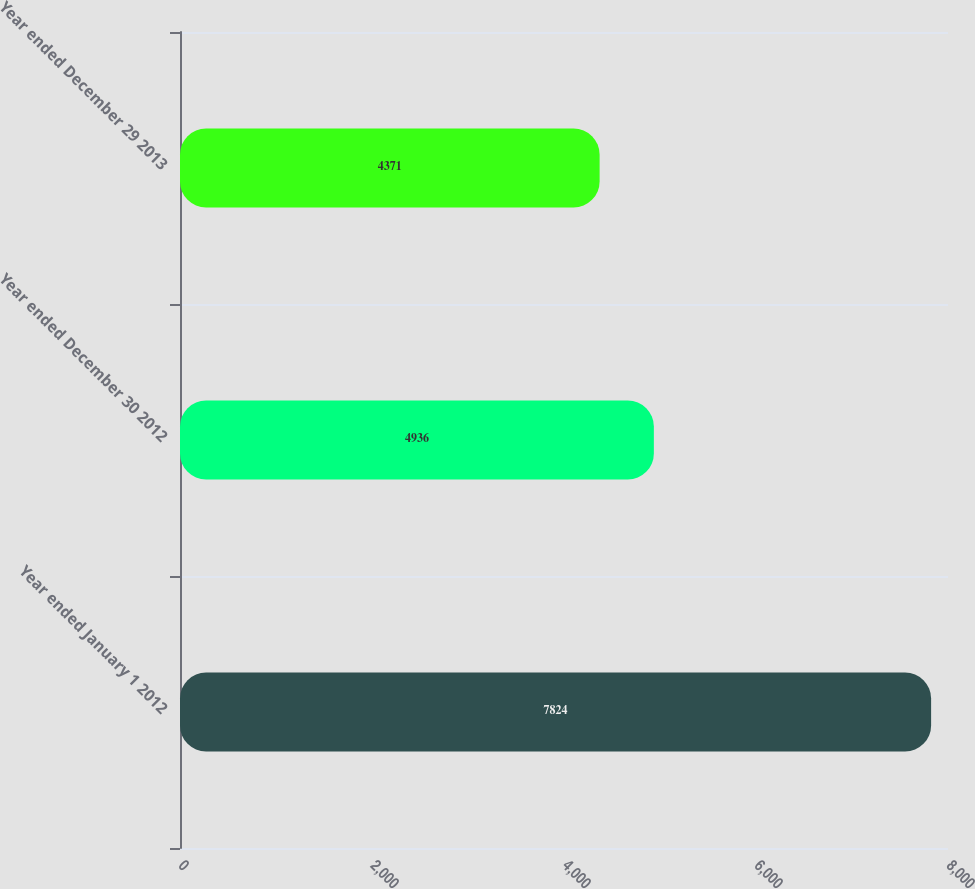Convert chart. <chart><loc_0><loc_0><loc_500><loc_500><bar_chart><fcel>Year ended January 1 2012<fcel>Year ended December 30 2012<fcel>Year ended December 29 2013<nl><fcel>7824<fcel>4936<fcel>4371<nl></chart> 